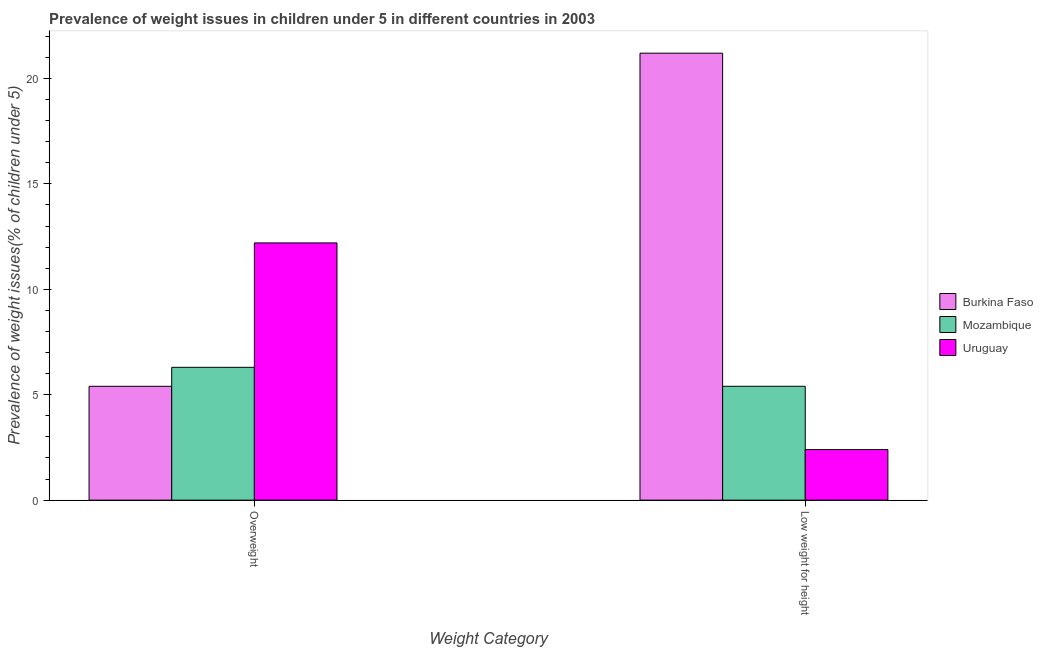How many groups of bars are there?
Offer a very short reply. 2. Are the number of bars on each tick of the X-axis equal?
Give a very brief answer. Yes. How many bars are there on the 2nd tick from the left?
Make the answer very short. 3. How many bars are there on the 2nd tick from the right?
Offer a very short reply. 3. What is the label of the 2nd group of bars from the left?
Your answer should be very brief. Low weight for height. What is the percentage of overweight children in Burkina Faso?
Your response must be concise. 5.4. Across all countries, what is the maximum percentage of underweight children?
Keep it short and to the point. 21.2. Across all countries, what is the minimum percentage of underweight children?
Make the answer very short. 2.4. In which country was the percentage of overweight children maximum?
Provide a succinct answer. Uruguay. In which country was the percentage of underweight children minimum?
Provide a succinct answer. Uruguay. What is the total percentage of underweight children in the graph?
Give a very brief answer. 29. What is the difference between the percentage of overweight children in Uruguay and that in Burkina Faso?
Offer a very short reply. 6.8. What is the difference between the percentage of overweight children in Uruguay and the percentage of underweight children in Burkina Faso?
Provide a short and direct response. -9. What is the average percentage of overweight children per country?
Ensure brevity in your answer.  7.97. What is the difference between the percentage of underweight children and percentage of overweight children in Burkina Faso?
Make the answer very short. 15.8. What is the ratio of the percentage of overweight children in Uruguay to that in Burkina Faso?
Make the answer very short. 2.26. In how many countries, is the percentage of underweight children greater than the average percentage of underweight children taken over all countries?
Your response must be concise. 1. What does the 2nd bar from the left in Low weight for height represents?
Your answer should be very brief. Mozambique. What does the 2nd bar from the right in Low weight for height represents?
Give a very brief answer. Mozambique. Are all the bars in the graph horizontal?
Provide a short and direct response. No. How many countries are there in the graph?
Offer a very short reply. 3. Are the values on the major ticks of Y-axis written in scientific E-notation?
Your answer should be very brief. No. Does the graph contain any zero values?
Your answer should be very brief. No. Does the graph contain grids?
Ensure brevity in your answer.  No. What is the title of the graph?
Your response must be concise. Prevalence of weight issues in children under 5 in different countries in 2003. Does "Jamaica" appear as one of the legend labels in the graph?
Offer a terse response. No. What is the label or title of the X-axis?
Give a very brief answer. Weight Category. What is the label or title of the Y-axis?
Ensure brevity in your answer.  Prevalence of weight issues(% of children under 5). What is the Prevalence of weight issues(% of children under 5) in Burkina Faso in Overweight?
Your response must be concise. 5.4. What is the Prevalence of weight issues(% of children under 5) in Mozambique in Overweight?
Make the answer very short. 6.3. What is the Prevalence of weight issues(% of children under 5) in Uruguay in Overweight?
Keep it short and to the point. 12.2. What is the Prevalence of weight issues(% of children under 5) of Burkina Faso in Low weight for height?
Give a very brief answer. 21.2. What is the Prevalence of weight issues(% of children under 5) in Mozambique in Low weight for height?
Provide a short and direct response. 5.4. What is the Prevalence of weight issues(% of children under 5) in Uruguay in Low weight for height?
Provide a succinct answer. 2.4. Across all Weight Category, what is the maximum Prevalence of weight issues(% of children under 5) of Burkina Faso?
Your answer should be very brief. 21.2. Across all Weight Category, what is the maximum Prevalence of weight issues(% of children under 5) of Mozambique?
Make the answer very short. 6.3. Across all Weight Category, what is the maximum Prevalence of weight issues(% of children under 5) of Uruguay?
Make the answer very short. 12.2. Across all Weight Category, what is the minimum Prevalence of weight issues(% of children under 5) in Burkina Faso?
Offer a very short reply. 5.4. Across all Weight Category, what is the minimum Prevalence of weight issues(% of children under 5) in Mozambique?
Make the answer very short. 5.4. Across all Weight Category, what is the minimum Prevalence of weight issues(% of children under 5) in Uruguay?
Your answer should be very brief. 2.4. What is the total Prevalence of weight issues(% of children under 5) in Burkina Faso in the graph?
Your answer should be very brief. 26.6. What is the total Prevalence of weight issues(% of children under 5) in Mozambique in the graph?
Your answer should be very brief. 11.7. What is the total Prevalence of weight issues(% of children under 5) of Uruguay in the graph?
Make the answer very short. 14.6. What is the difference between the Prevalence of weight issues(% of children under 5) of Burkina Faso in Overweight and that in Low weight for height?
Make the answer very short. -15.8. What is the difference between the Prevalence of weight issues(% of children under 5) of Mozambique in Overweight and that in Low weight for height?
Ensure brevity in your answer.  0.9. What is the difference between the Prevalence of weight issues(% of children under 5) of Uruguay in Overweight and that in Low weight for height?
Your answer should be compact. 9.8. What is the difference between the Prevalence of weight issues(% of children under 5) of Burkina Faso in Overweight and the Prevalence of weight issues(% of children under 5) of Mozambique in Low weight for height?
Your response must be concise. 0. What is the difference between the Prevalence of weight issues(% of children under 5) of Burkina Faso in Overweight and the Prevalence of weight issues(% of children under 5) of Uruguay in Low weight for height?
Offer a very short reply. 3. What is the average Prevalence of weight issues(% of children under 5) of Mozambique per Weight Category?
Give a very brief answer. 5.85. What is the difference between the Prevalence of weight issues(% of children under 5) of Mozambique and Prevalence of weight issues(% of children under 5) of Uruguay in Overweight?
Ensure brevity in your answer.  -5.9. What is the difference between the Prevalence of weight issues(% of children under 5) in Burkina Faso and Prevalence of weight issues(% of children under 5) in Uruguay in Low weight for height?
Ensure brevity in your answer.  18.8. What is the ratio of the Prevalence of weight issues(% of children under 5) of Burkina Faso in Overweight to that in Low weight for height?
Provide a short and direct response. 0.25. What is the ratio of the Prevalence of weight issues(% of children under 5) of Mozambique in Overweight to that in Low weight for height?
Provide a short and direct response. 1.17. What is the ratio of the Prevalence of weight issues(% of children under 5) of Uruguay in Overweight to that in Low weight for height?
Keep it short and to the point. 5.08. What is the difference between the highest and the second highest Prevalence of weight issues(% of children under 5) in Burkina Faso?
Your answer should be very brief. 15.8. What is the difference between the highest and the second highest Prevalence of weight issues(% of children under 5) in Mozambique?
Your response must be concise. 0.9. What is the difference between the highest and the lowest Prevalence of weight issues(% of children under 5) of Burkina Faso?
Offer a terse response. 15.8. What is the difference between the highest and the lowest Prevalence of weight issues(% of children under 5) of Mozambique?
Your answer should be compact. 0.9. What is the difference between the highest and the lowest Prevalence of weight issues(% of children under 5) of Uruguay?
Provide a short and direct response. 9.8. 